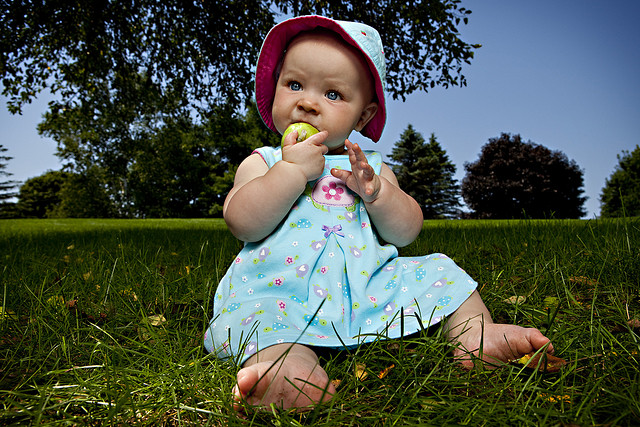<image>What kind of shorts is the child wearing? The child is not wearing shorts. What kind of shorts is the child wearing? The child is not wearing any shorts in the image. 